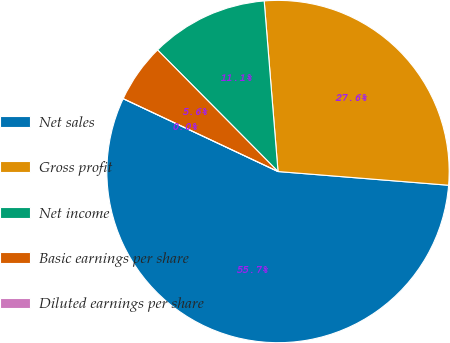Convert chart. <chart><loc_0><loc_0><loc_500><loc_500><pie_chart><fcel>Net sales<fcel>Gross profit<fcel>Net income<fcel>Basic earnings per share<fcel>Diluted earnings per share<nl><fcel>55.72%<fcel>27.56%<fcel>11.14%<fcel>5.57%<fcel>0.0%<nl></chart> 